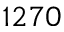Convert formula to latex. <formula><loc_0><loc_0><loc_500><loc_500>1 2 7 0</formula> 